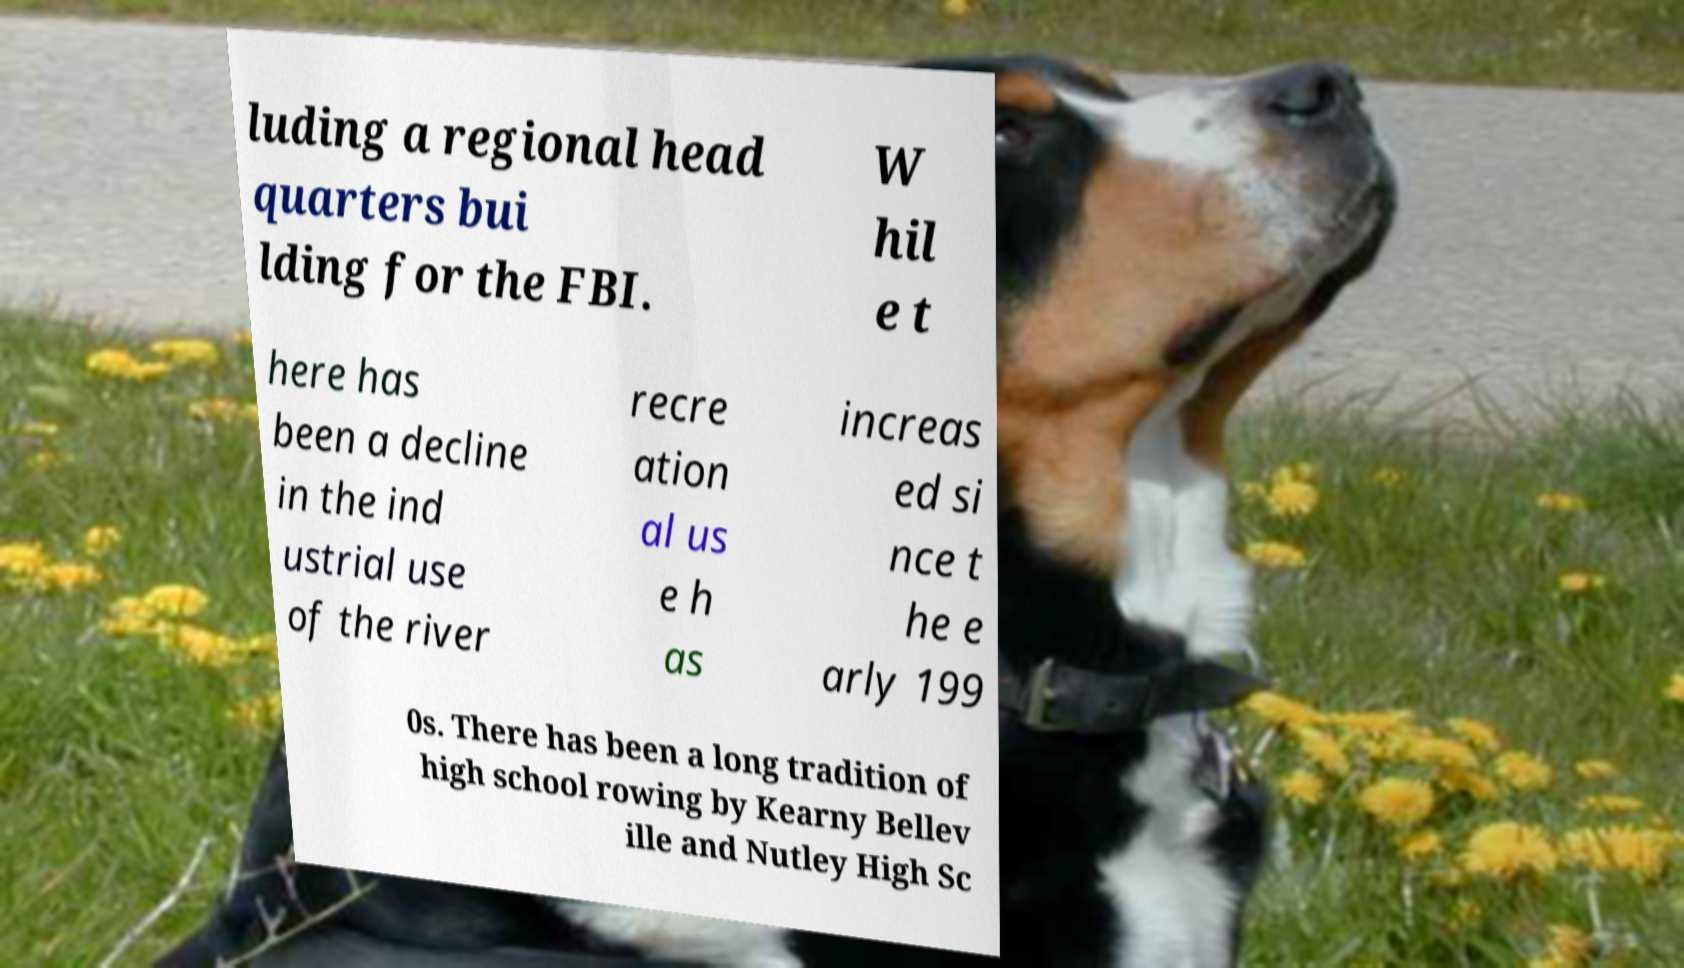I need the written content from this picture converted into text. Can you do that? luding a regional head quarters bui lding for the FBI. W hil e t here has been a decline in the ind ustrial use of the river recre ation al us e h as increas ed si nce t he e arly 199 0s. There has been a long tradition of high school rowing by Kearny Bellev ille and Nutley High Sc 